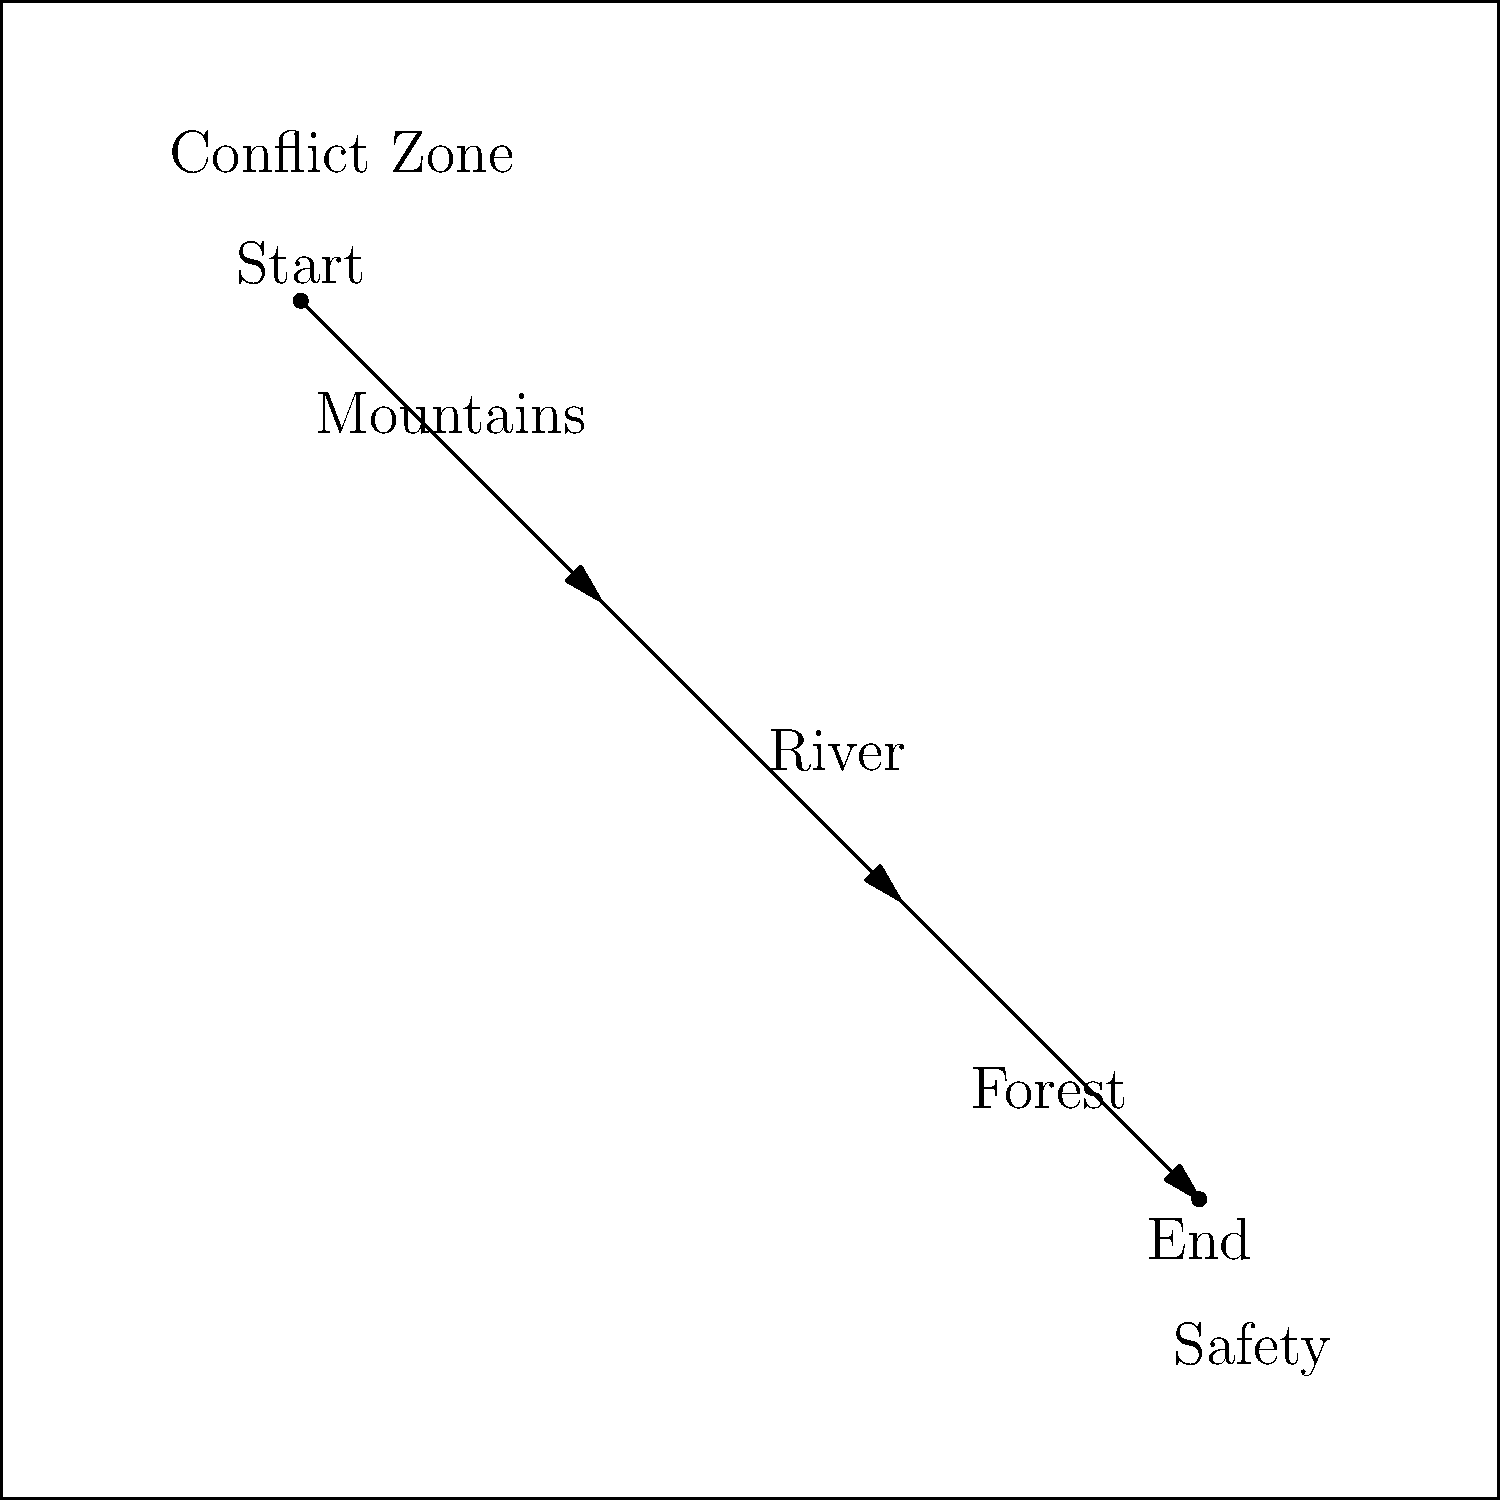Based on the map showing the journey from a conflict zone to safety, what is the correct order of geographical features encountered along the path? To answer this question, we need to carefully examine the map and follow the path from the conflict zone to safety:

1. The journey starts in the top-left corner, labeled "Conflict Zone".
2. The path is indicated by arrows moving diagonally across the map.
3. As we follow the path, we encounter labeled geographical features:
   a. First, we see "Mountains" near the beginning of the journey.
   b. Next, we cross a "River" in the middle of the path.
   c. Finally, we pass through a "Forest" before reaching safety.
4. The journey ends in the bottom-right corner, labeled "Safety".

Therefore, the correct order of geographical features encountered along the path is: Mountains, River, Forest.
Answer: Mountains, River, Forest 